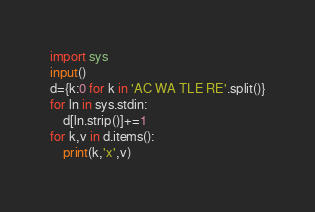Convert code to text. <code><loc_0><loc_0><loc_500><loc_500><_Python_>import sys
input()
d={k:0 for k in 'AC WA TLE RE'.split()}
for ln in sys.stdin:
    d[ln.strip()]+=1
for k,v in d.items():
    print(k,'x',v)
</code> 